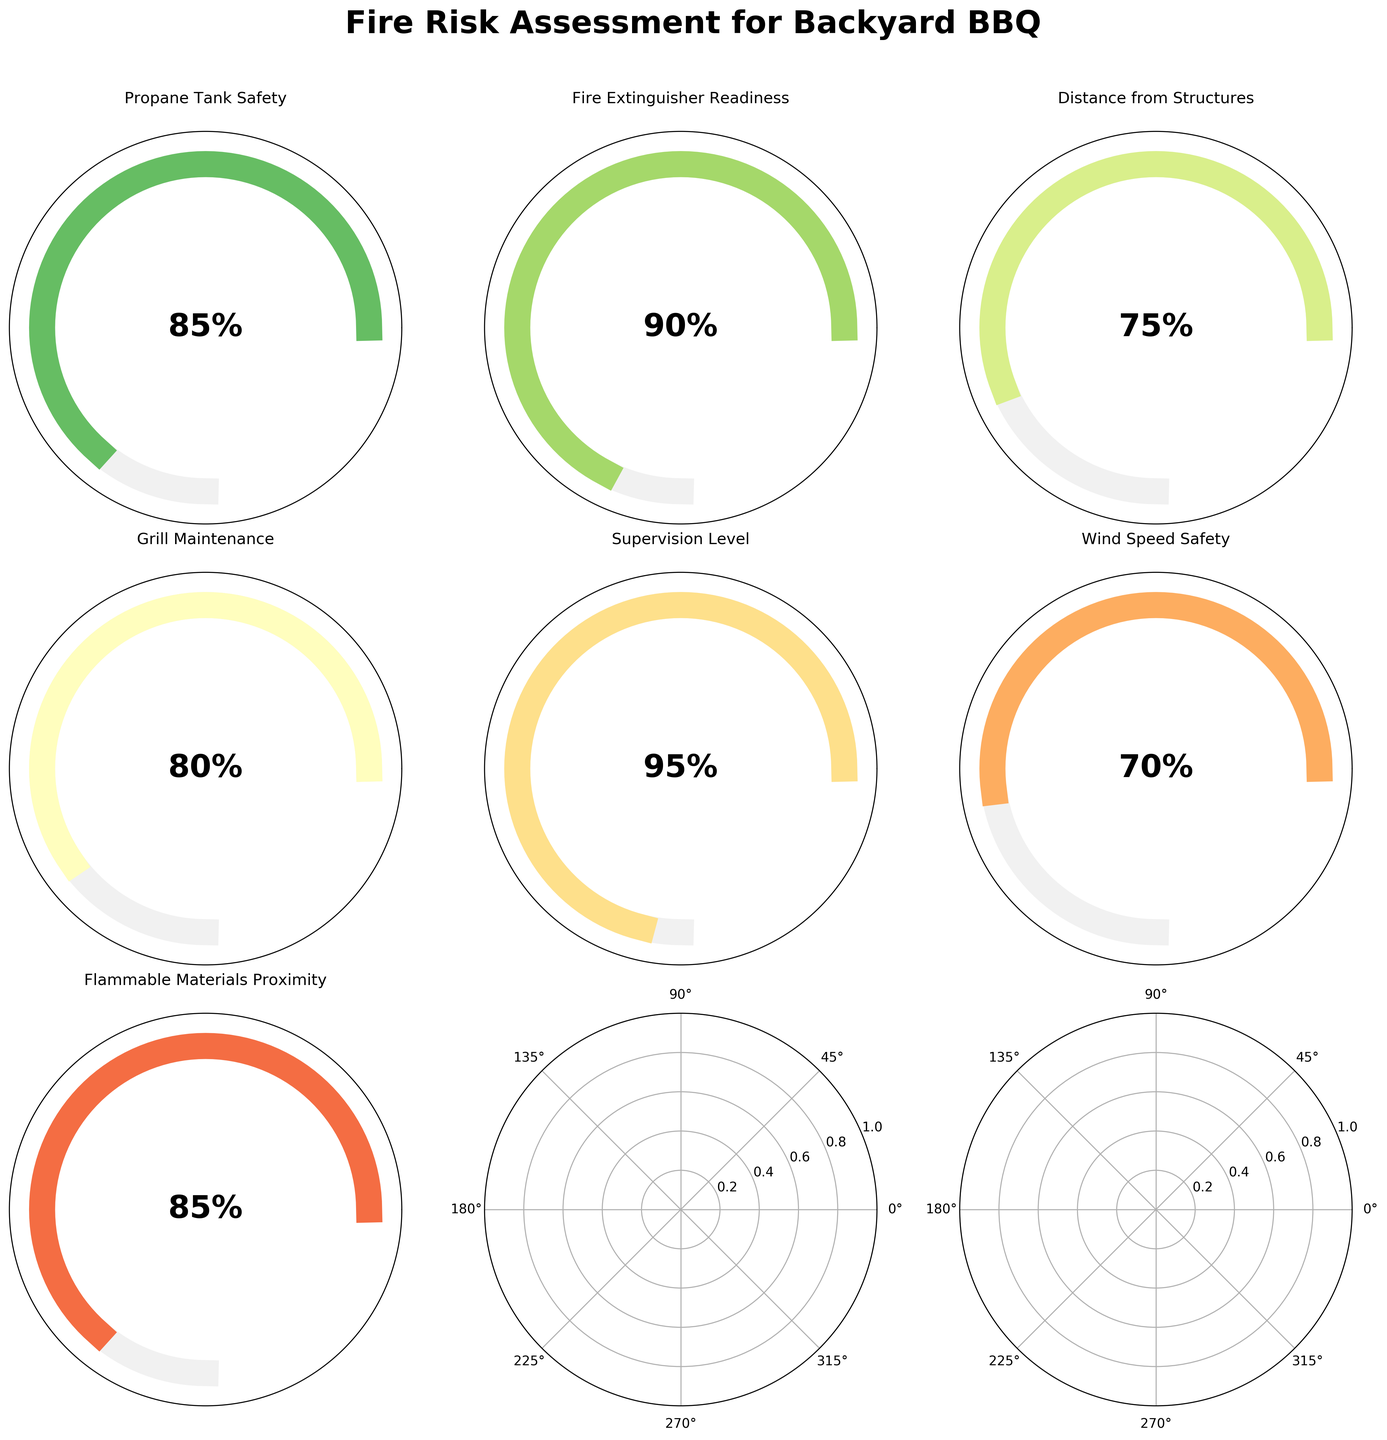What's the highest value category? From the gauge charts, you can see the percentages for each category. The highest value is 95%, which corresponds to the "Supervision Level" category.
Answer: Supervision Level Which category has the lowest safety level? Looking at the gauge charts, the category with the lowest percentage is "Wind Speed Safety" with 70%.
Answer: Wind Speed Safety What is the average value of all categories combined? Sum all category values: 85 + 90 + 75 + 80 + 95 + 70 + 85 = 580. There are 7 categories, so the average = 580 / 7 ≈ 82.86.
Answer: 82.86 How many categories have a safety level over 80%? By observing the gauge charts, the categories over 80% are: "Propane Tank Safety", "Fire Extinguisher Readiness", "Grill Maintenance", "Supervision Level", and "Flammable Materials Proximity". Count them: 5 categories.
Answer: 5 Compare "Propane Tank Safety" and "Wind Speed Safety"; which is safer and by how much? "Propane Tank Safety" is 85% safe while "Wind Speed Safety" is 70% safe. Difference: 85% - 70% = 15%.
Answer: Propane Tank Safety by 15% What is the fire risk assessment category with the closest value to 75%? The category with a value closest to 75% is "Distance from Structures" which is exactly 75%.
Answer: Distance from Structures What is the combined score of "Propane Tank Safety" and "Grill Maintenance"? Add the values of both categories: 85 + 80 = 165.
Answer: 165 If you had to improve one category below 80%, which one would you choose based on its value? The categories below 80% are "Distance from Structures" (75%) and "Wind Speed Safety" (70%). Based on the values, "Wind Speed Safety" needs more improvement.
Answer: Wind Speed Safety How does "Fire Extinguisher Readiness" compare to "Flammable Materials Proximity"? "Fire Extinguisher Readiness" is 90%, while "Flammable Materials Proximity" is 85%. Hence, "Fire Extinguisher Readiness" is safer by 5%.
Answer: Fire Extinguisher Readiness by 5% 